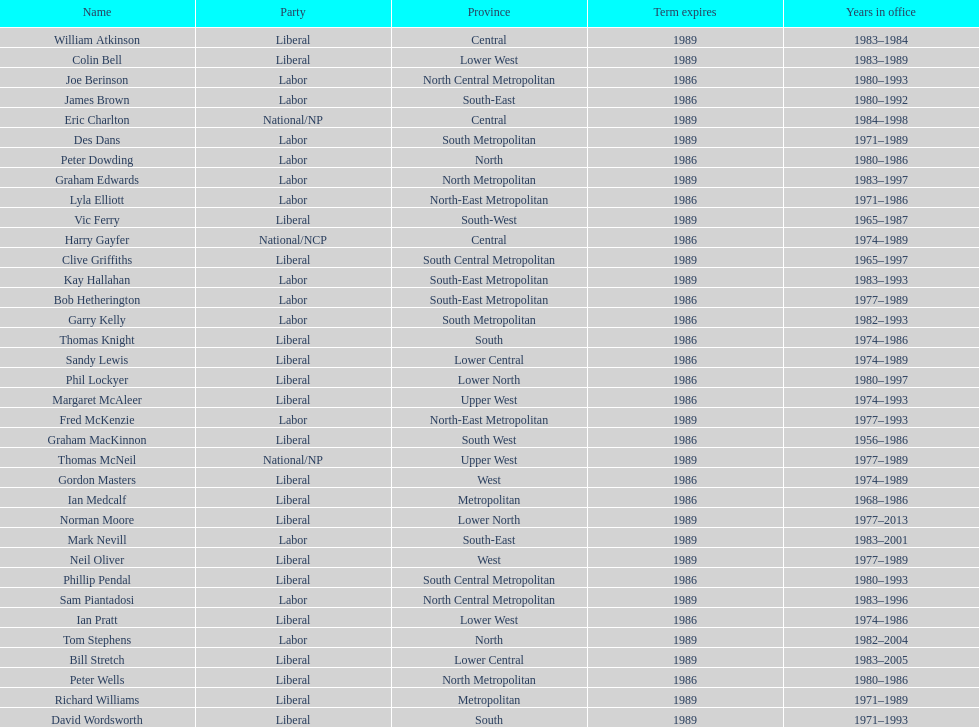In which party can one find the greatest number of members? Liberal. 